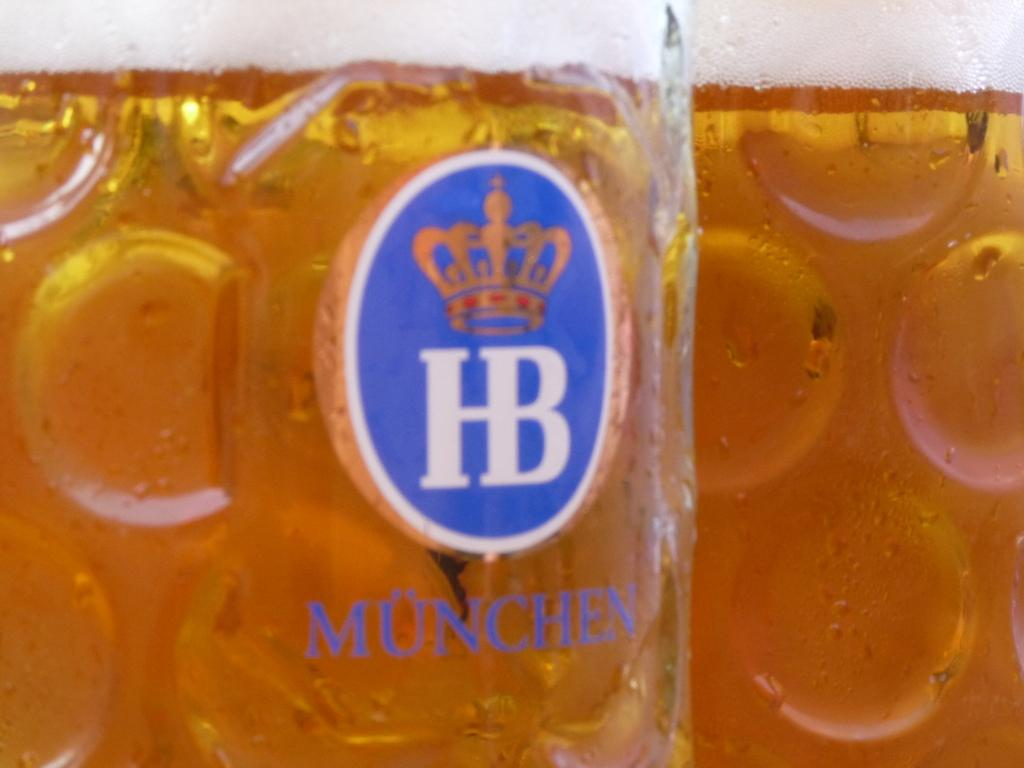Provide a one-sentence caption for the provided image. A drinking glass with a kings crown on it and the letters HB. 